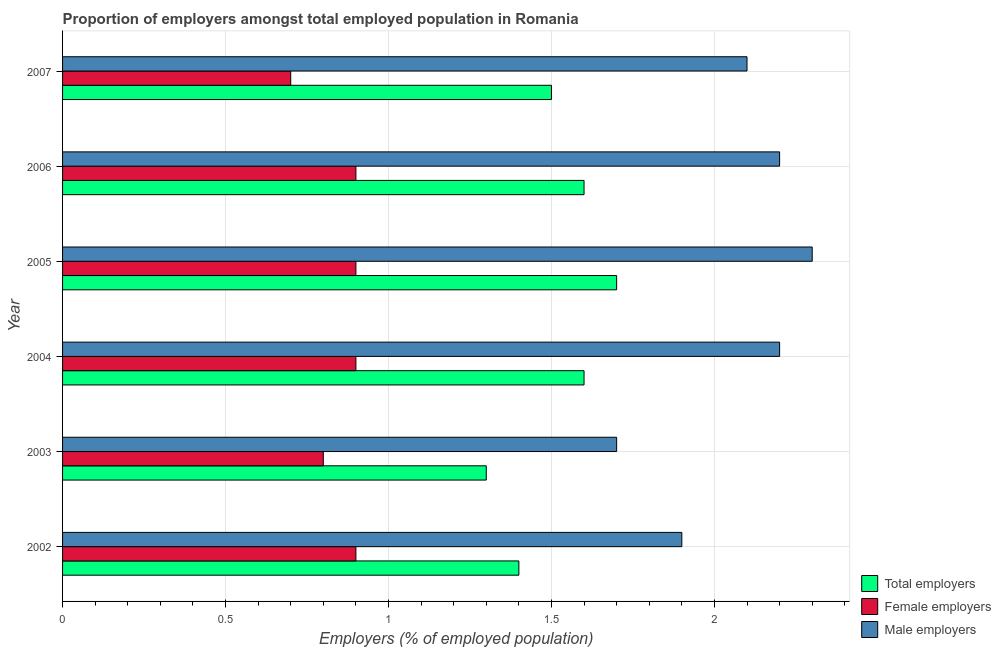How many groups of bars are there?
Your answer should be compact. 6. Are the number of bars per tick equal to the number of legend labels?
Offer a terse response. Yes. How many bars are there on the 2nd tick from the top?
Keep it short and to the point. 3. How many bars are there on the 2nd tick from the bottom?
Make the answer very short. 3. What is the label of the 3rd group of bars from the top?
Offer a very short reply. 2005. What is the percentage of total employers in 2002?
Provide a short and direct response. 1.4. Across all years, what is the maximum percentage of total employers?
Give a very brief answer. 1.7. Across all years, what is the minimum percentage of male employers?
Your answer should be compact. 1.7. In which year was the percentage of male employers maximum?
Offer a terse response. 2005. What is the total percentage of male employers in the graph?
Keep it short and to the point. 12.4. What is the difference between the percentage of female employers in 2003 and the percentage of male employers in 2006?
Ensure brevity in your answer.  -1.4. In the year 2003, what is the difference between the percentage of total employers and percentage of male employers?
Ensure brevity in your answer.  -0.4. What is the ratio of the percentage of total employers in 2003 to that in 2007?
Offer a very short reply. 0.87. Is the difference between the percentage of male employers in 2006 and 2007 greater than the difference between the percentage of female employers in 2006 and 2007?
Offer a very short reply. No. Is the sum of the percentage of male employers in 2004 and 2005 greater than the maximum percentage of female employers across all years?
Offer a terse response. Yes. What does the 2nd bar from the top in 2003 represents?
Your response must be concise. Female employers. What does the 3rd bar from the bottom in 2005 represents?
Provide a short and direct response. Male employers. Is it the case that in every year, the sum of the percentage of total employers and percentage of female employers is greater than the percentage of male employers?
Provide a succinct answer. Yes. Are all the bars in the graph horizontal?
Give a very brief answer. Yes. How many years are there in the graph?
Give a very brief answer. 6. What is the difference between two consecutive major ticks on the X-axis?
Your response must be concise. 0.5. Where does the legend appear in the graph?
Make the answer very short. Bottom right. How many legend labels are there?
Your answer should be very brief. 3. How are the legend labels stacked?
Provide a short and direct response. Vertical. What is the title of the graph?
Make the answer very short. Proportion of employers amongst total employed population in Romania. Does "Taxes on goods and services" appear as one of the legend labels in the graph?
Offer a very short reply. No. What is the label or title of the X-axis?
Make the answer very short. Employers (% of employed population). What is the Employers (% of employed population) of Total employers in 2002?
Your answer should be compact. 1.4. What is the Employers (% of employed population) of Female employers in 2002?
Your answer should be compact. 0.9. What is the Employers (% of employed population) in Male employers in 2002?
Keep it short and to the point. 1.9. What is the Employers (% of employed population) in Total employers in 2003?
Provide a succinct answer. 1.3. What is the Employers (% of employed population) of Female employers in 2003?
Your answer should be compact. 0.8. What is the Employers (% of employed population) in Male employers in 2003?
Offer a very short reply. 1.7. What is the Employers (% of employed population) of Total employers in 2004?
Provide a succinct answer. 1.6. What is the Employers (% of employed population) of Female employers in 2004?
Keep it short and to the point. 0.9. What is the Employers (% of employed population) of Male employers in 2004?
Provide a succinct answer. 2.2. What is the Employers (% of employed population) in Total employers in 2005?
Offer a very short reply. 1.7. What is the Employers (% of employed population) of Female employers in 2005?
Provide a succinct answer. 0.9. What is the Employers (% of employed population) in Male employers in 2005?
Your answer should be very brief. 2.3. What is the Employers (% of employed population) of Total employers in 2006?
Provide a succinct answer. 1.6. What is the Employers (% of employed population) in Female employers in 2006?
Provide a succinct answer. 0.9. What is the Employers (% of employed population) of Male employers in 2006?
Your answer should be very brief. 2.2. What is the Employers (% of employed population) of Female employers in 2007?
Provide a short and direct response. 0.7. What is the Employers (% of employed population) of Male employers in 2007?
Your answer should be very brief. 2.1. Across all years, what is the maximum Employers (% of employed population) in Total employers?
Ensure brevity in your answer.  1.7. Across all years, what is the maximum Employers (% of employed population) of Female employers?
Offer a very short reply. 0.9. Across all years, what is the maximum Employers (% of employed population) of Male employers?
Ensure brevity in your answer.  2.3. Across all years, what is the minimum Employers (% of employed population) in Total employers?
Provide a short and direct response. 1.3. Across all years, what is the minimum Employers (% of employed population) of Female employers?
Your answer should be very brief. 0.7. Across all years, what is the minimum Employers (% of employed population) of Male employers?
Provide a short and direct response. 1.7. What is the total Employers (% of employed population) of Total employers in the graph?
Ensure brevity in your answer.  9.1. What is the total Employers (% of employed population) of Female employers in the graph?
Make the answer very short. 5.1. What is the difference between the Employers (% of employed population) in Total employers in 2002 and that in 2003?
Provide a succinct answer. 0.1. What is the difference between the Employers (% of employed population) in Female employers in 2002 and that in 2004?
Give a very brief answer. 0. What is the difference between the Employers (% of employed population) in Total employers in 2002 and that in 2005?
Give a very brief answer. -0.3. What is the difference between the Employers (% of employed population) of Female employers in 2002 and that in 2005?
Offer a very short reply. 0. What is the difference between the Employers (% of employed population) in Total employers in 2002 and that in 2007?
Offer a very short reply. -0.1. What is the difference between the Employers (% of employed population) of Male employers in 2002 and that in 2007?
Keep it short and to the point. -0.2. What is the difference between the Employers (% of employed population) in Female employers in 2003 and that in 2004?
Give a very brief answer. -0.1. What is the difference between the Employers (% of employed population) in Male employers in 2003 and that in 2004?
Offer a very short reply. -0.5. What is the difference between the Employers (% of employed population) in Total employers in 2003 and that in 2006?
Your response must be concise. -0.3. What is the difference between the Employers (% of employed population) in Male employers in 2003 and that in 2007?
Make the answer very short. -0.4. What is the difference between the Employers (% of employed population) of Female employers in 2004 and that in 2005?
Make the answer very short. 0. What is the difference between the Employers (% of employed population) in Total employers in 2004 and that in 2006?
Your answer should be very brief. 0. What is the difference between the Employers (% of employed population) in Female employers in 2004 and that in 2006?
Make the answer very short. 0. What is the difference between the Employers (% of employed population) in Male employers in 2004 and that in 2006?
Offer a very short reply. 0. What is the difference between the Employers (% of employed population) of Female employers in 2004 and that in 2007?
Give a very brief answer. 0.2. What is the difference between the Employers (% of employed population) of Total employers in 2005 and that in 2006?
Give a very brief answer. 0.1. What is the difference between the Employers (% of employed population) in Male employers in 2005 and that in 2006?
Keep it short and to the point. 0.1. What is the difference between the Employers (% of employed population) of Total employers in 2005 and that in 2007?
Give a very brief answer. 0.2. What is the difference between the Employers (% of employed population) of Female employers in 2005 and that in 2007?
Offer a terse response. 0.2. What is the difference between the Employers (% of employed population) of Male employers in 2005 and that in 2007?
Provide a short and direct response. 0.2. What is the difference between the Employers (% of employed population) in Total employers in 2006 and that in 2007?
Give a very brief answer. 0.1. What is the difference between the Employers (% of employed population) in Female employers in 2006 and that in 2007?
Offer a terse response. 0.2. What is the difference between the Employers (% of employed population) in Total employers in 2002 and the Employers (% of employed population) in Female employers in 2003?
Make the answer very short. 0.6. What is the difference between the Employers (% of employed population) of Total employers in 2002 and the Employers (% of employed population) of Male employers in 2004?
Provide a succinct answer. -0.8. What is the difference between the Employers (% of employed population) of Female employers in 2002 and the Employers (% of employed population) of Male employers in 2004?
Provide a short and direct response. -1.3. What is the difference between the Employers (% of employed population) of Total employers in 2002 and the Employers (% of employed population) of Female employers in 2006?
Give a very brief answer. 0.5. What is the difference between the Employers (% of employed population) of Total employers in 2002 and the Employers (% of employed population) of Male employers in 2006?
Provide a succinct answer. -0.8. What is the difference between the Employers (% of employed population) of Female employers in 2002 and the Employers (% of employed population) of Male employers in 2006?
Provide a succinct answer. -1.3. What is the difference between the Employers (% of employed population) in Total employers in 2002 and the Employers (% of employed population) in Female employers in 2007?
Your answer should be very brief. 0.7. What is the difference between the Employers (% of employed population) of Female employers in 2002 and the Employers (% of employed population) of Male employers in 2007?
Your answer should be compact. -1.2. What is the difference between the Employers (% of employed population) in Total employers in 2003 and the Employers (% of employed population) in Female employers in 2005?
Keep it short and to the point. 0.4. What is the difference between the Employers (% of employed population) in Total employers in 2003 and the Employers (% of employed population) in Male employers in 2005?
Offer a terse response. -1. What is the difference between the Employers (% of employed population) in Female employers in 2003 and the Employers (% of employed population) in Male employers in 2005?
Your answer should be compact. -1.5. What is the difference between the Employers (% of employed population) of Total employers in 2003 and the Employers (% of employed population) of Male employers in 2006?
Provide a short and direct response. -0.9. What is the difference between the Employers (% of employed population) in Female employers in 2003 and the Employers (% of employed population) in Male employers in 2006?
Keep it short and to the point. -1.4. What is the difference between the Employers (% of employed population) in Total employers in 2003 and the Employers (% of employed population) in Male employers in 2007?
Keep it short and to the point. -0.8. What is the difference between the Employers (% of employed population) of Total employers in 2004 and the Employers (% of employed population) of Male employers in 2005?
Offer a terse response. -0.7. What is the difference between the Employers (% of employed population) in Total employers in 2004 and the Employers (% of employed population) in Female employers in 2006?
Provide a short and direct response. 0.7. What is the difference between the Employers (% of employed population) in Total employers in 2004 and the Employers (% of employed population) in Female employers in 2007?
Your answer should be compact. 0.9. What is the difference between the Employers (% of employed population) in Total employers in 2004 and the Employers (% of employed population) in Male employers in 2007?
Keep it short and to the point. -0.5. What is the difference between the Employers (% of employed population) in Total employers in 2006 and the Employers (% of employed population) in Female employers in 2007?
Provide a succinct answer. 0.9. What is the difference between the Employers (% of employed population) of Female employers in 2006 and the Employers (% of employed population) of Male employers in 2007?
Your answer should be very brief. -1.2. What is the average Employers (% of employed population) in Total employers per year?
Provide a succinct answer. 1.52. What is the average Employers (% of employed population) of Male employers per year?
Provide a succinct answer. 2.07. In the year 2004, what is the difference between the Employers (% of employed population) of Total employers and Employers (% of employed population) of Female employers?
Ensure brevity in your answer.  0.7. In the year 2005, what is the difference between the Employers (% of employed population) of Total employers and Employers (% of employed population) of Female employers?
Your response must be concise. 0.8. In the year 2005, what is the difference between the Employers (% of employed population) in Total employers and Employers (% of employed population) in Male employers?
Keep it short and to the point. -0.6. In the year 2005, what is the difference between the Employers (% of employed population) of Female employers and Employers (% of employed population) of Male employers?
Offer a terse response. -1.4. In the year 2006, what is the difference between the Employers (% of employed population) in Total employers and Employers (% of employed population) in Female employers?
Make the answer very short. 0.7. In the year 2007, what is the difference between the Employers (% of employed population) of Total employers and Employers (% of employed population) of Female employers?
Provide a succinct answer. 0.8. What is the ratio of the Employers (% of employed population) in Total employers in 2002 to that in 2003?
Make the answer very short. 1.08. What is the ratio of the Employers (% of employed population) of Female employers in 2002 to that in 2003?
Offer a very short reply. 1.12. What is the ratio of the Employers (% of employed population) of Male employers in 2002 to that in 2003?
Provide a short and direct response. 1.12. What is the ratio of the Employers (% of employed population) of Female employers in 2002 to that in 2004?
Your response must be concise. 1. What is the ratio of the Employers (% of employed population) in Male employers in 2002 to that in 2004?
Provide a succinct answer. 0.86. What is the ratio of the Employers (% of employed population) of Total employers in 2002 to that in 2005?
Your answer should be very brief. 0.82. What is the ratio of the Employers (% of employed population) in Male employers in 2002 to that in 2005?
Keep it short and to the point. 0.83. What is the ratio of the Employers (% of employed population) in Total employers in 2002 to that in 2006?
Offer a very short reply. 0.88. What is the ratio of the Employers (% of employed population) in Male employers in 2002 to that in 2006?
Your answer should be very brief. 0.86. What is the ratio of the Employers (% of employed population) of Male employers in 2002 to that in 2007?
Make the answer very short. 0.9. What is the ratio of the Employers (% of employed population) of Total employers in 2003 to that in 2004?
Offer a terse response. 0.81. What is the ratio of the Employers (% of employed population) of Male employers in 2003 to that in 2004?
Your answer should be compact. 0.77. What is the ratio of the Employers (% of employed population) in Total employers in 2003 to that in 2005?
Your answer should be very brief. 0.76. What is the ratio of the Employers (% of employed population) of Male employers in 2003 to that in 2005?
Provide a succinct answer. 0.74. What is the ratio of the Employers (% of employed population) in Total employers in 2003 to that in 2006?
Your answer should be compact. 0.81. What is the ratio of the Employers (% of employed population) in Male employers in 2003 to that in 2006?
Provide a succinct answer. 0.77. What is the ratio of the Employers (% of employed population) of Total employers in 2003 to that in 2007?
Your answer should be compact. 0.87. What is the ratio of the Employers (% of employed population) in Male employers in 2003 to that in 2007?
Provide a succinct answer. 0.81. What is the ratio of the Employers (% of employed population) of Male employers in 2004 to that in 2005?
Your answer should be compact. 0.96. What is the ratio of the Employers (% of employed population) in Total employers in 2004 to that in 2007?
Your answer should be very brief. 1.07. What is the ratio of the Employers (% of employed population) in Female employers in 2004 to that in 2007?
Your response must be concise. 1.29. What is the ratio of the Employers (% of employed population) in Male employers in 2004 to that in 2007?
Ensure brevity in your answer.  1.05. What is the ratio of the Employers (% of employed population) in Total employers in 2005 to that in 2006?
Keep it short and to the point. 1.06. What is the ratio of the Employers (% of employed population) in Female employers in 2005 to that in 2006?
Your response must be concise. 1. What is the ratio of the Employers (% of employed population) in Male employers in 2005 to that in 2006?
Provide a short and direct response. 1.05. What is the ratio of the Employers (% of employed population) of Total employers in 2005 to that in 2007?
Your response must be concise. 1.13. What is the ratio of the Employers (% of employed population) of Female employers in 2005 to that in 2007?
Ensure brevity in your answer.  1.29. What is the ratio of the Employers (% of employed population) in Male employers in 2005 to that in 2007?
Your answer should be very brief. 1.1. What is the ratio of the Employers (% of employed population) in Total employers in 2006 to that in 2007?
Give a very brief answer. 1.07. What is the ratio of the Employers (% of employed population) of Male employers in 2006 to that in 2007?
Provide a short and direct response. 1.05. What is the difference between the highest and the second highest Employers (% of employed population) of Total employers?
Offer a very short reply. 0.1. What is the difference between the highest and the second highest Employers (% of employed population) of Female employers?
Offer a very short reply. 0. What is the difference between the highest and the lowest Employers (% of employed population) in Total employers?
Offer a very short reply. 0.4. What is the difference between the highest and the lowest Employers (% of employed population) in Female employers?
Your response must be concise. 0.2. What is the difference between the highest and the lowest Employers (% of employed population) in Male employers?
Your answer should be compact. 0.6. 